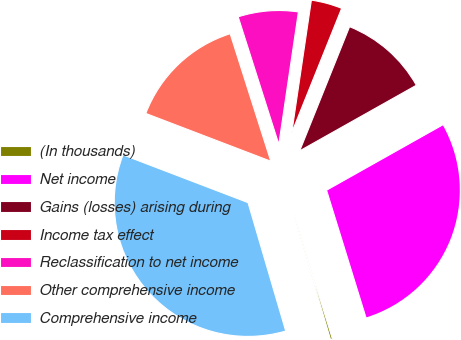<chart> <loc_0><loc_0><loc_500><loc_500><pie_chart><fcel>(In thousands)<fcel>Net income<fcel>Gains (losses) arising during<fcel>Income tax effect<fcel>Reclassification to net income<fcel>Other comprehensive income<fcel>Comprehensive income<nl><fcel>0.23%<fcel>28.38%<fcel>10.77%<fcel>3.74%<fcel>7.25%<fcel>14.28%<fcel>35.36%<nl></chart> 